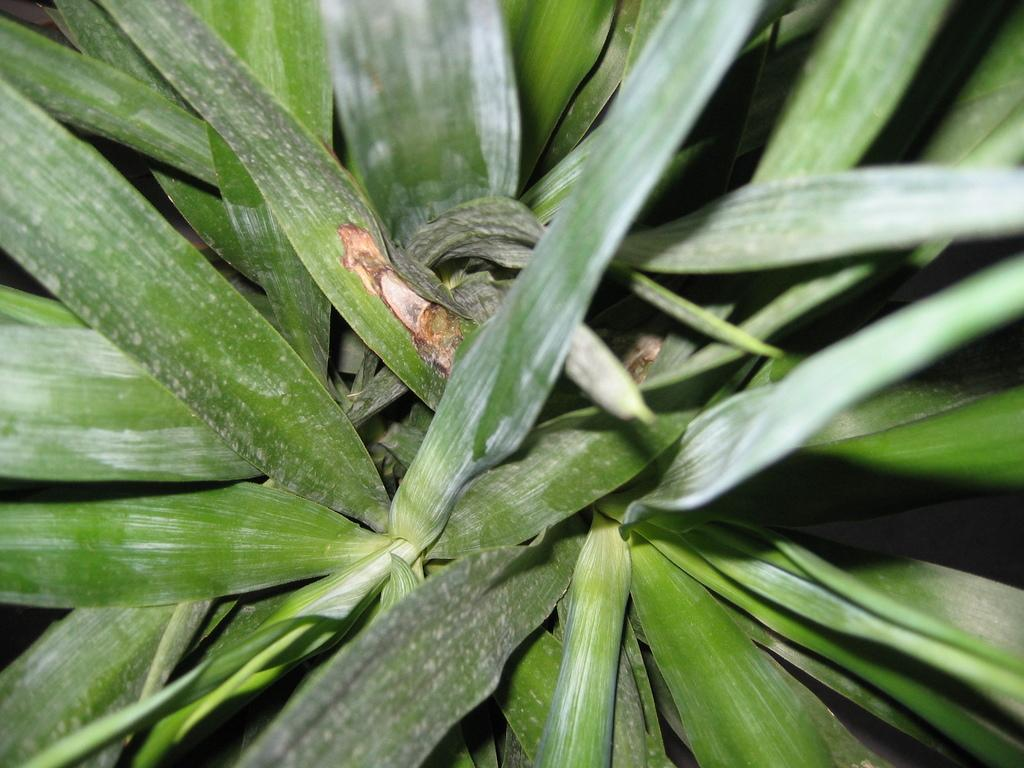What type of living organism can be seen in the image? There is a plant in the image. What type of basket is being used to carry the plant in the image? There is no basket present in the image; it only features a plant. What type of death is depicted in the image? There is no depiction of death in the image; it only features a plant. 